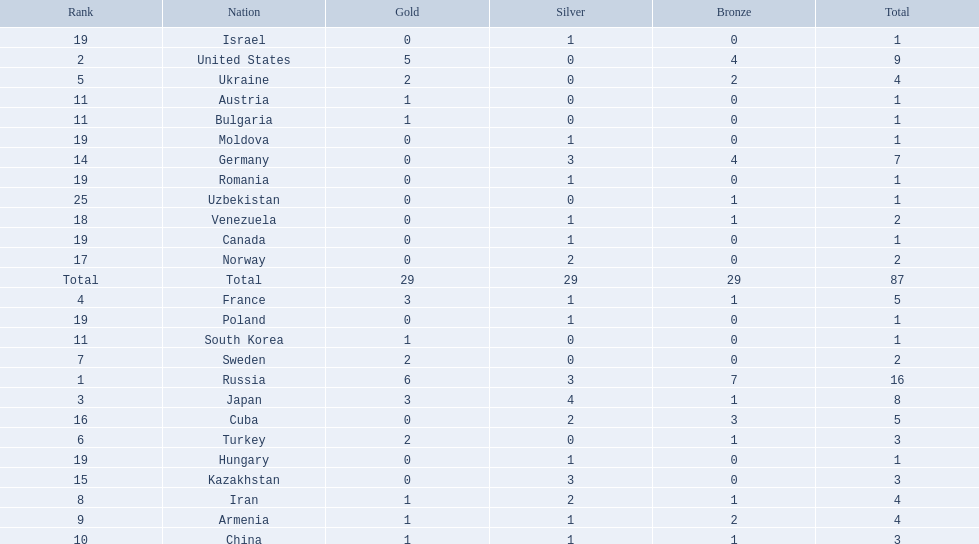Which nations participated in the 1995 world wrestling championships? Russia, United States, Japan, France, Ukraine, Turkey, Sweden, Iran, Armenia, China, Austria, Bulgaria, South Korea, Germany, Kazakhstan, Cuba, Norway, Venezuela, Canada, Hungary, Israel, Moldova, Poland, Romania, Uzbekistan. And between iran and germany, which one placed in the top 10? Germany. Which countries competed in the 1995 world wrestling championships? Russia, United States, Japan, France, Ukraine, Turkey, Sweden, Iran, Armenia, China, Austria, Bulgaria, South Korea, Germany, Kazakhstan, Cuba, Norway, Venezuela, Canada, Hungary, Israel, Moldova, Poland, Romania, Uzbekistan. What country won only one medal? Austria, Bulgaria, South Korea, Canada, Hungary, Israel, Moldova, Poland, Romania, Uzbekistan. Which of these won a bronze medal? Uzbekistan. 